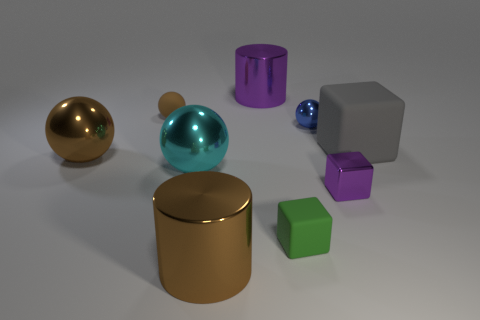Subtract all small blocks. How many blocks are left? 1 Subtract all brown cylinders. How many cylinders are left? 1 Subtract 2 balls. How many balls are left? 2 Subtract all cylinders. How many objects are left? 7 Subtract all gray cubes. How many green spheres are left? 0 Subtract all brown cubes. Subtract all purple balls. How many cubes are left? 3 Add 4 big gray objects. How many big gray objects are left? 5 Add 2 rubber cubes. How many rubber cubes exist? 4 Subtract 1 blue balls. How many objects are left? 8 Subtract all tiny green blocks. Subtract all cyan shiny things. How many objects are left? 7 